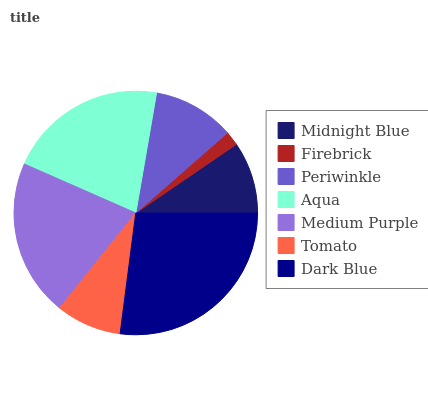Is Firebrick the minimum?
Answer yes or no. Yes. Is Dark Blue the maximum?
Answer yes or no. Yes. Is Periwinkle the minimum?
Answer yes or no. No. Is Periwinkle the maximum?
Answer yes or no. No. Is Periwinkle greater than Firebrick?
Answer yes or no. Yes. Is Firebrick less than Periwinkle?
Answer yes or no. Yes. Is Firebrick greater than Periwinkle?
Answer yes or no. No. Is Periwinkle less than Firebrick?
Answer yes or no. No. Is Periwinkle the high median?
Answer yes or no. Yes. Is Periwinkle the low median?
Answer yes or no. Yes. Is Medium Purple the high median?
Answer yes or no. No. Is Aqua the low median?
Answer yes or no. No. 